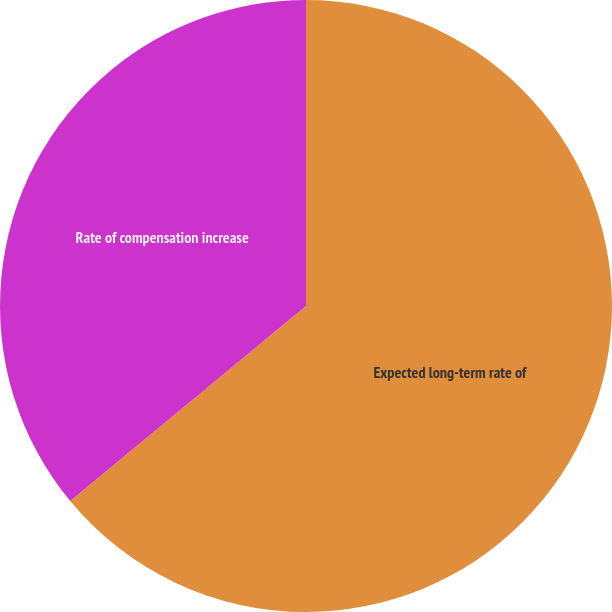Convert chart to OTSL. <chart><loc_0><loc_0><loc_500><loc_500><pie_chart><fcel>Expected long-term rate of<fcel>Rate of compensation increase<nl><fcel>64.0%<fcel>36.0%<nl></chart> 